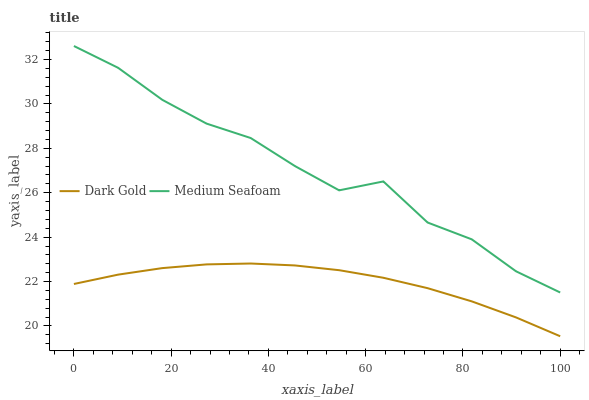Does Dark Gold have the minimum area under the curve?
Answer yes or no. Yes. Does Medium Seafoam have the maximum area under the curve?
Answer yes or no. Yes. Does Dark Gold have the maximum area under the curve?
Answer yes or no. No. Is Dark Gold the smoothest?
Answer yes or no. Yes. Is Medium Seafoam the roughest?
Answer yes or no. Yes. Is Dark Gold the roughest?
Answer yes or no. No. Does Medium Seafoam have the highest value?
Answer yes or no. Yes. Does Dark Gold have the highest value?
Answer yes or no. No. Is Dark Gold less than Medium Seafoam?
Answer yes or no. Yes. Is Medium Seafoam greater than Dark Gold?
Answer yes or no. Yes. Does Dark Gold intersect Medium Seafoam?
Answer yes or no. No. 